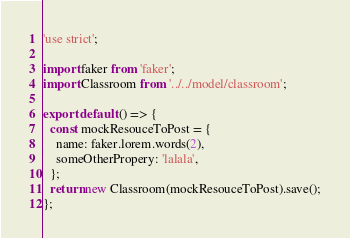<code> <loc_0><loc_0><loc_500><loc_500><_JavaScript_>'use strict';

import faker from 'faker';
import Classroom from '../../model/classroom';

export default () => {
  const mockResouceToPost = {
    name: faker.lorem.words(2),
    someOtherPropery: 'lalala',
  };
  return new Classroom(mockResouceToPost).save();
};
</code> 